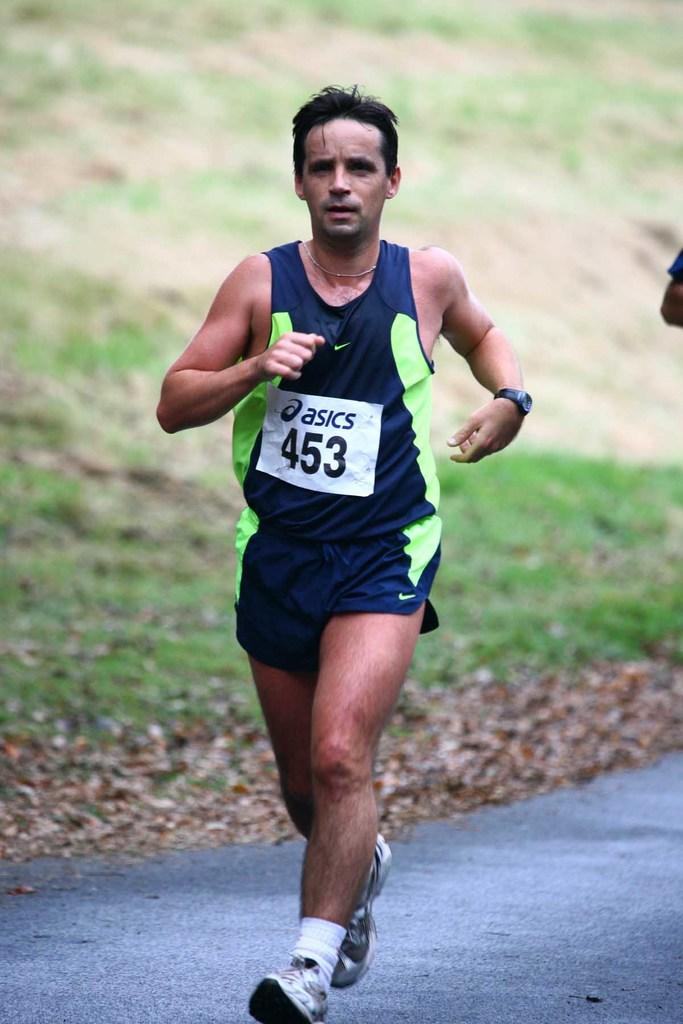<image>
Summarize the visual content of the image. A man running with the number 453 on his Nike t-shirt. 